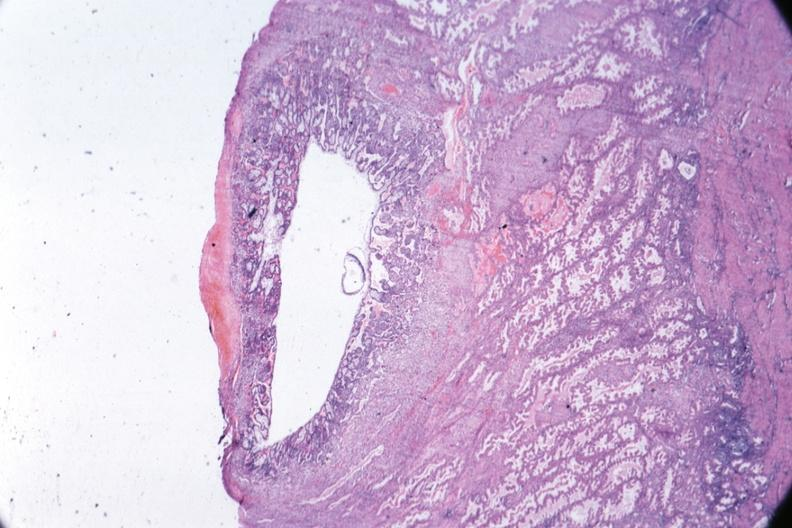s fetus developing very early present?
Answer the question using a single word or phrase. Yes 